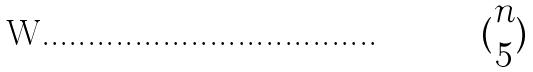Convert formula to latex. <formula><loc_0><loc_0><loc_500><loc_500>( \begin{matrix} n \\ 5 \end{matrix} )</formula> 